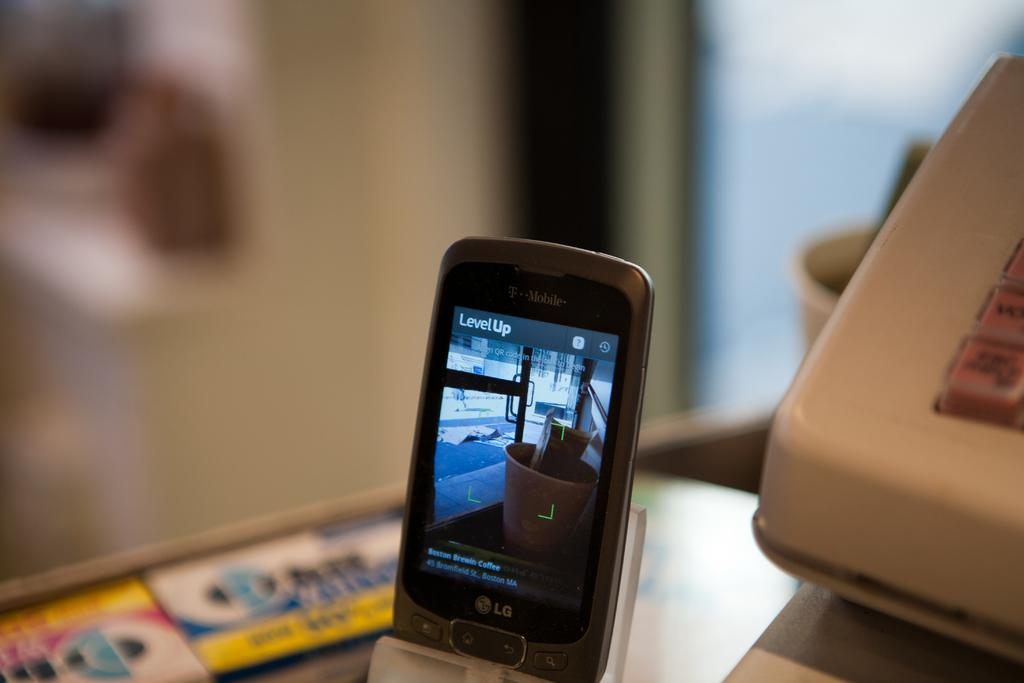Provide a one-sentence caption for the provided image. a cell phone propped up with the word level up on the screen. 